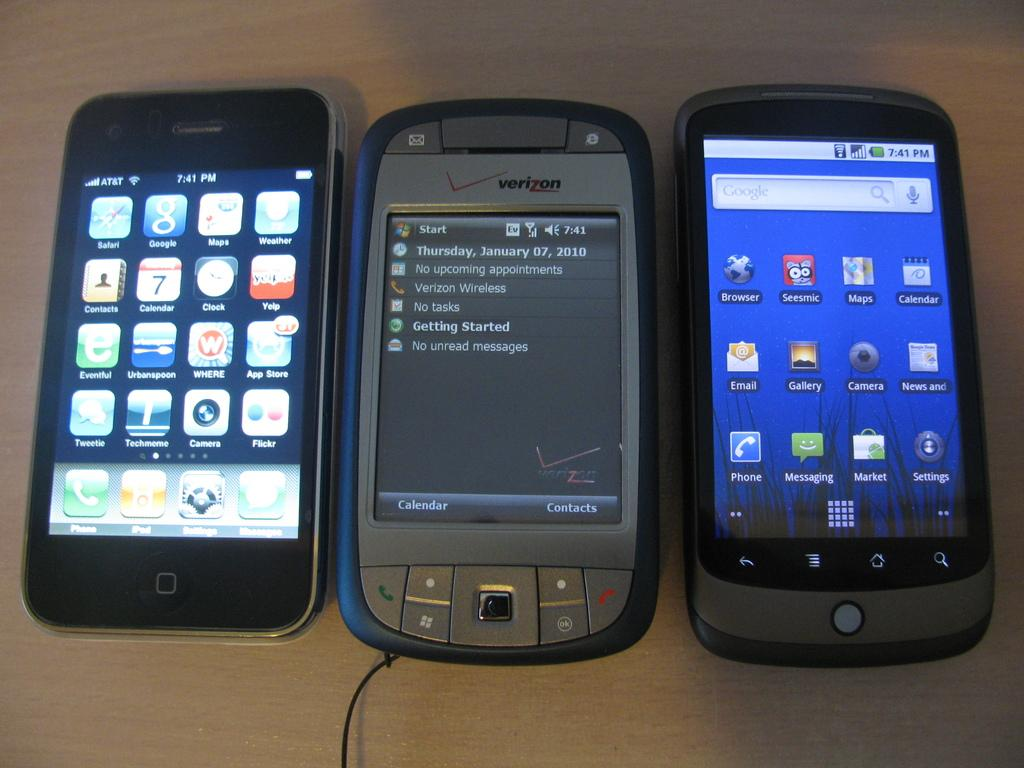<image>
Relay a brief, clear account of the picture shown. Three old cell phones on a table including a Verizon phone and an Apple iPhone. 